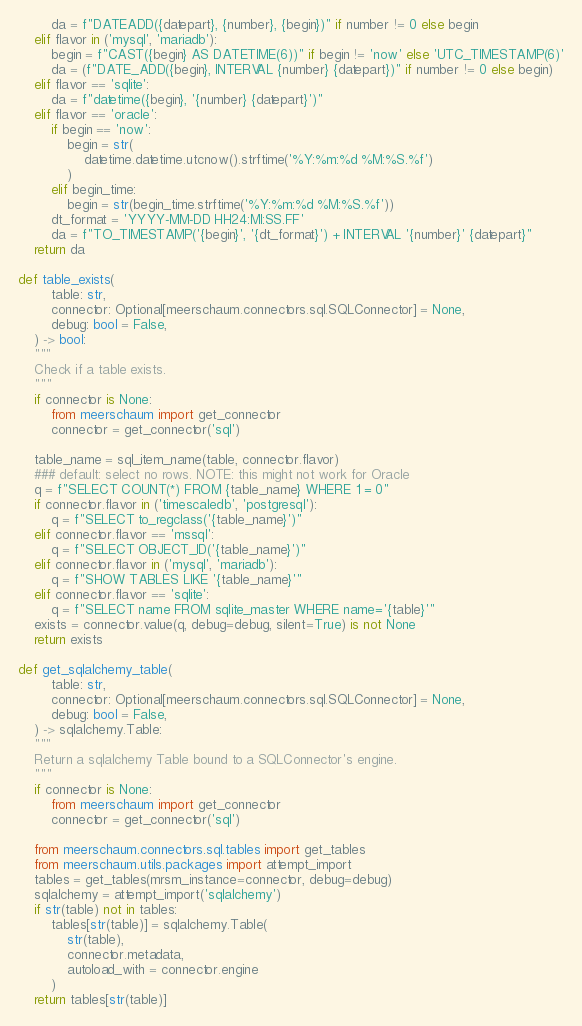<code> <loc_0><loc_0><loc_500><loc_500><_Python_>        da = f"DATEADD({datepart}, {number}, {begin})" if number != 0 else begin
    elif flavor in ('mysql', 'mariadb'):
        begin = f"CAST({begin} AS DATETIME(6))" if begin != 'now' else 'UTC_TIMESTAMP(6)'
        da = (f"DATE_ADD({begin}, INTERVAL {number} {datepart})" if number != 0 else begin)
    elif flavor == 'sqlite':
        da = f"datetime({begin}, '{number} {datepart}')"
    elif flavor == 'oracle':
        if begin == 'now':
            begin = str(
                datetime.datetime.utcnow().strftime('%Y:%m:%d %M:%S.%f')
            )
        elif begin_time:
            begin = str(begin_time.strftime('%Y:%m:%d %M:%S.%f'))
        dt_format = 'YYYY-MM-DD HH24:MI:SS.FF'
        da = f"TO_TIMESTAMP('{begin}', '{dt_format}') + INTERVAL '{number}' {datepart}"
    return da

def table_exists(
        table: str,
        connector: Optional[meerschaum.connectors.sql.SQLConnector] = None,
        debug: bool = False,
    ) -> bool:
    """
    Check if a table exists.
    """
    if connector is None:
        from meerschaum import get_connector
        connector = get_connector('sql')

    table_name = sql_item_name(table, connector.flavor)
    ### default: select no rows. NOTE: this might not work for Oracle
    q = f"SELECT COUNT(*) FROM {table_name} WHERE 1 = 0"
    if connector.flavor in ('timescaledb', 'postgresql'):
        q = f"SELECT to_regclass('{table_name}')"
    elif connector.flavor == 'mssql':
        q = f"SELECT OBJECT_ID('{table_name}')"
    elif connector.flavor in ('mysql', 'mariadb'):
        q = f"SHOW TABLES LIKE '{table_name}'"
    elif connector.flavor == 'sqlite':
        q = f"SELECT name FROM sqlite_master WHERE name='{table}'"
    exists = connector.value(q, debug=debug, silent=True) is not None
    return exists

def get_sqlalchemy_table(
        table: str,
        connector: Optional[meerschaum.connectors.sql.SQLConnector] = None,
        debug: bool = False,
    ) -> sqlalchemy.Table:
    """
    Return a sqlalchemy Table bound to a SQLConnector's engine.
    """
    if connector is None:
        from meerschaum import get_connector
        connector = get_connector('sql')

    from meerschaum.connectors.sql.tables import get_tables
    from meerschaum.utils.packages import attempt_import
    tables = get_tables(mrsm_instance=connector, debug=debug)
    sqlalchemy = attempt_import('sqlalchemy')
    if str(table) not in tables:
        tables[str(table)] = sqlalchemy.Table(
            str(table),
            connector.metadata,
            autoload_with = connector.engine
        )
    return tables[str(table)]

</code> 